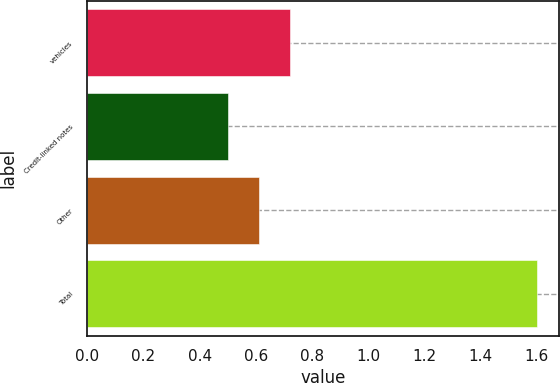Convert chart. <chart><loc_0><loc_0><loc_500><loc_500><bar_chart><fcel>vehicles<fcel>Credit-linked notes<fcel>Other<fcel>Total<nl><fcel>0.72<fcel>0.5<fcel>0.61<fcel>1.6<nl></chart> 